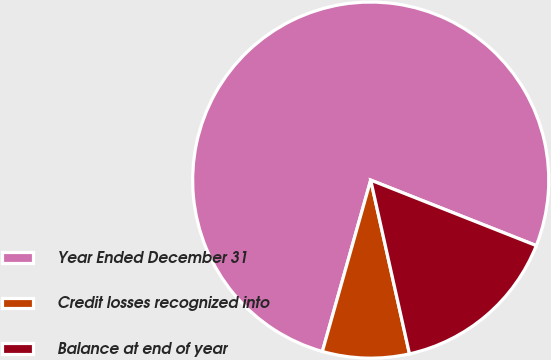Convert chart. <chart><loc_0><loc_0><loc_500><loc_500><pie_chart><fcel>Year Ended December 31<fcel>Credit losses recognized into<fcel>Balance at end of year<nl><fcel>76.62%<fcel>7.87%<fcel>15.51%<nl></chart> 